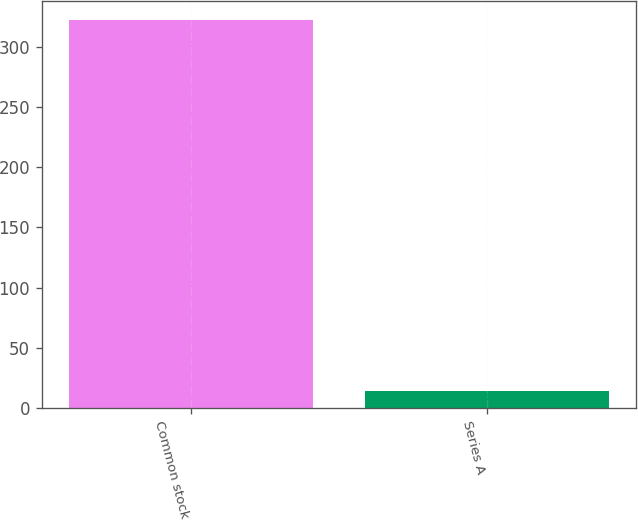Convert chart. <chart><loc_0><loc_0><loc_500><loc_500><bar_chart><fcel>Common stock<fcel>Series A<nl><fcel>322<fcel>14<nl></chart> 